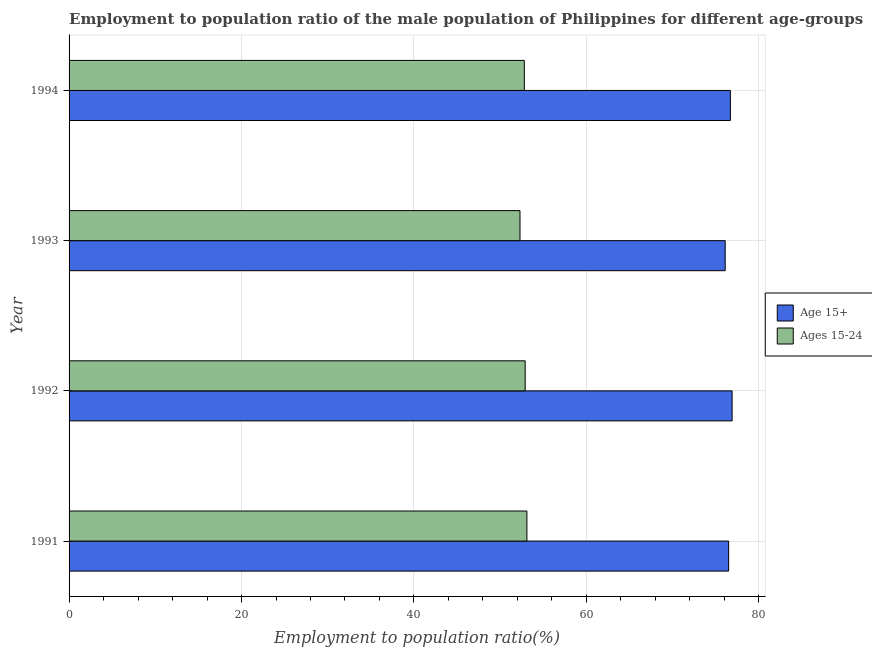How many different coloured bars are there?
Give a very brief answer. 2. Are the number of bars per tick equal to the number of legend labels?
Provide a succinct answer. Yes. How many bars are there on the 3rd tick from the bottom?
Make the answer very short. 2. What is the employment to population ratio(age 15+) in 1991?
Keep it short and to the point. 76.5. Across all years, what is the maximum employment to population ratio(age 15-24)?
Offer a terse response. 53.1. Across all years, what is the minimum employment to population ratio(age 15+)?
Ensure brevity in your answer.  76.1. What is the total employment to population ratio(age 15+) in the graph?
Offer a terse response. 306.2. What is the difference between the employment to population ratio(age 15+) in 1993 and the employment to population ratio(age 15-24) in 1992?
Offer a terse response. 23.2. What is the average employment to population ratio(age 15-24) per year?
Provide a succinct answer. 52.77. In the year 1994, what is the difference between the employment to population ratio(age 15-24) and employment to population ratio(age 15+)?
Make the answer very short. -23.9. In how many years, is the employment to population ratio(age 15+) greater than 8 %?
Ensure brevity in your answer.  4. What is the ratio of the employment to population ratio(age 15+) in 1991 to that in 1992?
Keep it short and to the point. 0.99. Is the employment to population ratio(age 15+) in 1991 less than that in 1994?
Provide a short and direct response. Yes. What does the 1st bar from the top in 1991 represents?
Your answer should be compact. Ages 15-24. What does the 1st bar from the bottom in 1994 represents?
Offer a very short reply. Age 15+. How many bars are there?
Provide a succinct answer. 8. Are all the bars in the graph horizontal?
Make the answer very short. Yes. What is the difference between two consecutive major ticks on the X-axis?
Offer a very short reply. 20. Are the values on the major ticks of X-axis written in scientific E-notation?
Your answer should be very brief. No. Does the graph contain any zero values?
Your answer should be very brief. No. Does the graph contain grids?
Give a very brief answer. Yes. Where does the legend appear in the graph?
Offer a very short reply. Center right. What is the title of the graph?
Give a very brief answer. Employment to population ratio of the male population of Philippines for different age-groups. Does "Mobile cellular" appear as one of the legend labels in the graph?
Provide a succinct answer. No. What is the label or title of the X-axis?
Offer a very short reply. Employment to population ratio(%). What is the Employment to population ratio(%) in Age 15+ in 1991?
Keep it short and to the point. 76.5. What is the Employment to population ratio(%) of Ages 15-24 in 1991?
Ensure brevity in your answer.  53.1. What is the Employment to population ratio(%) of Age 15+ in 1992?
Your response must be concise. 76.9. What is the Employment to population ratio(%) in Ages 15-24 in 1992?
Make the answer very short. 52.9. What is the Employment to population ratio(%) in Age 15+ in 1993?
Provide a short and direct response. 76.1. What is the Employment to population ratio(%) in Ages 15-24 in 1993?
Ensure brevity in your answer.  52.3. What is the Employment to population ratio(%) of Age 15+ in 1994?
Offer a terse response. 76.7. What is the Employment to population ratio(%) in Ages 15-24 in 1994?
Give a very brief answer. 52.8. Across all years, what is the maximum Employment to population ratio(%) of Age 15+?
Provide a short and direct response. 76.9. Across all years, what is the maximum Employment to population ratio(%) of Ages 15-24?
Your answer should be compact. 53.1. Across all years, what is the minimum Employment to population ratio(%) in Age 15+?
Keep it short and to the point. 76.1. Across all years, what is the minimum Employment to population ratio(%) of Ages 15-24?
Ensure brevity in your answer.  52.3. What is the total Employment to population ratio(%) in Age 15+ in the graph?
Your response must be concise. 306.2. What is the total Employment to population ratio(%) in Ages 15-24 in the graph?
Make the answer very short. 211.1. What is the difference between the Employment to population ratio(%) in Age 15+ in 1991 and that in 1992?
Make the answer very short. -0.4. What is the difference between the Employment to population ratio(%) in Age 15+ in 1991 and that in 1993?
Provide a succinct answer. 0.4. What is the difference between the Employment to population ratio(%) of Age 15+ in 1991 and that in 1994?
Give a very brief answer. -0.2. What is the difference between the Employment to population ratio(%) in Ages 15-24 in 1991 and that in 1994?
Your answer should be compact. 0.3. What is the difference between the Employment to population ratio(%) in Age 15+ in 1992 and that in 1993?
Your answer should be compact. 0.8. What is the difference between the Employment to population ratio(%) in Age 15+ in 1993 and that in 1994?
Your answer should be compact. -0.6. What is the difference between the Employment to population ratio(%) of Ages 15-24 in 1993 and that in 1994?
Provide a succinct answer. -0.5. What is the difference between the Employment to population ratio(%) of Age 15+ in 1991 and the Employment to population ratio(%) of Ages 15-24 in 1992?
Give a very brief answer. 23.6. What is the difference between the Employment to population ratio(%) of Age 15+ in 1991 and the Employment to population ratio(%) of Ages 15-24 in 1993?
Your answer should be compact. 24.2. What is the difference between the Employment to population ratio(%) of Age 15+ in 1991 and the Employment to population ratio(%) of Ages 15-24 in 1994?
Offer a terse response. 23.7. What is the difference between the Employment to population ratio(%) in Age 15+ in 1992 and the Employment to population ratio(%) in Ages 15-24 in 1993?
Your response must be concise. 24.6. What is the difference between the Employment to population ratio(%) of Age 15+ in 1992 and the Employment to population ratio(%) of Ages 15-24 in 1994?
Your answer should be compact. 24.1. What is the difference between the Employment to population ratio(%) in Age 15+ in 1993 and the Employment to population ratio(%) in Ages 15-24 in 1994?
Give a very brief answer. 23.3. What is the average Employment to population ratio(%) of Age 15+ per year?
Offer a terse response. 76.55. What is the average Employment to population ratio(%) of Ages 15-24 per year?
Offer a terse response. 52.77. In the year 1991, what is the difference between the Employment to population ratio(%) in Age 15+ and Employment to population ratio(%) in Ages 15-24?
Give a very brief answer. 23.4. In the year 1993, what is the difference between the Employment to population ratio(%) of Age 15+ and Employment to population ratio(%) of Ages 15-24?
Your answer should be very brief. 23.8. In the year 1994, what is the difference between the Employment to population ratio(%) of Age 15+ and Employment to population ratio(%) of Ages 15-24?
Offer a very short reply. 23.9. What is the ratio of the Employment to population ratio(%) of Age 15+ in 1991 to that in 1992?
Offer a terse response. 0.99. What is the ratio of the Employment to population ratio(%) in Ages 15-24 in 1991 to that in 1992?
Provide a succinct answer. 1. What is the ratio of the Employment to population ratio(%) of Ages 15-24 in 1991 to that in 1993?
Offer a very short reply. 1.02. What is the ratio of the Employment to population ratio(%) of Age 15+ in 1991 to that in 1994?
Offer a very short reply. 1. What is the ratio of the Employment to population ratio(%) in Ages 15-24 in 1991 to that in 1994?
Provide a short and direct response. 1.01. What is the ratio of the Employment to population ratio(%) of Age 15+ in 1992 to that in 1993?
Give a very brief answer. 1.01. What is the ratio of the Employment to population ratio(%) of Ages 15-24 in 1992 to that in 1993?
Your answer should be compact. 1.01. What is the ratio of the Employment to population ratio(%) in Age 15+ in 1992 to that in 1994?
Ensure brevity in your answer.  1. What is the ratio of the Employment to population ratio(%) of Age 15+ in 1993 to that in 1994?
Offer a terse response. 0.99. What is the difference between the highest and the second highest Employment to population ratio(%) in Age 15+?
Your answer should be very brief. 0.2. 